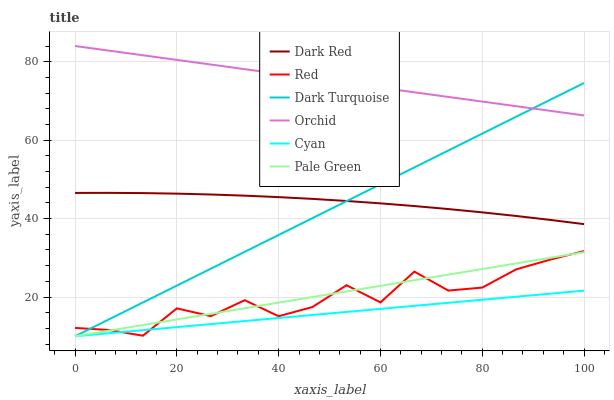Does Cyan have the minimum area under the curve?
Answer yes or no. Yes. Does Orchid have the maximum area under the curve?
Answer yes or no. Yes. Does Pale Green have the minimum area under the curve?
Answer yes or no. No. Does Pale Green have the maximum area under the curve?
Answer yes or no. No. Is Pale Green the smoothest?
Answer yes or no. Yes. Is Red the roughest?
Answer yes or no. Yes. Is Dark Turquoise the smoothest?
Answer yes or no. No. Is Dark Turquoise the roughest?
Answer yes or no. No. Does Pale Green have the lowest value?
Answer yes or no. Yes. Does Red have the lowest value?
Answer yes or no. No. Does Orchid have the highest value?
Answer yes or no. Yes. Does Pale Green have the highest value?
Answer yes or no. No. Is Pale Green less than Dark Red?
Answer yes or no. Yes. Is Dark Red greater than Red?
Answer yes or no. Yes. Does Dark Turquoise intersect Pale Green?
Answer yes or no. Yes. Is Dark Turquoise less than Pale Green?
Answer yes or no. No. Is Dark Turquoise greater than Pale Green?
Answer yes or no. No. Does Pale Green intersect Dark Red?
Answer yes or no. No. 